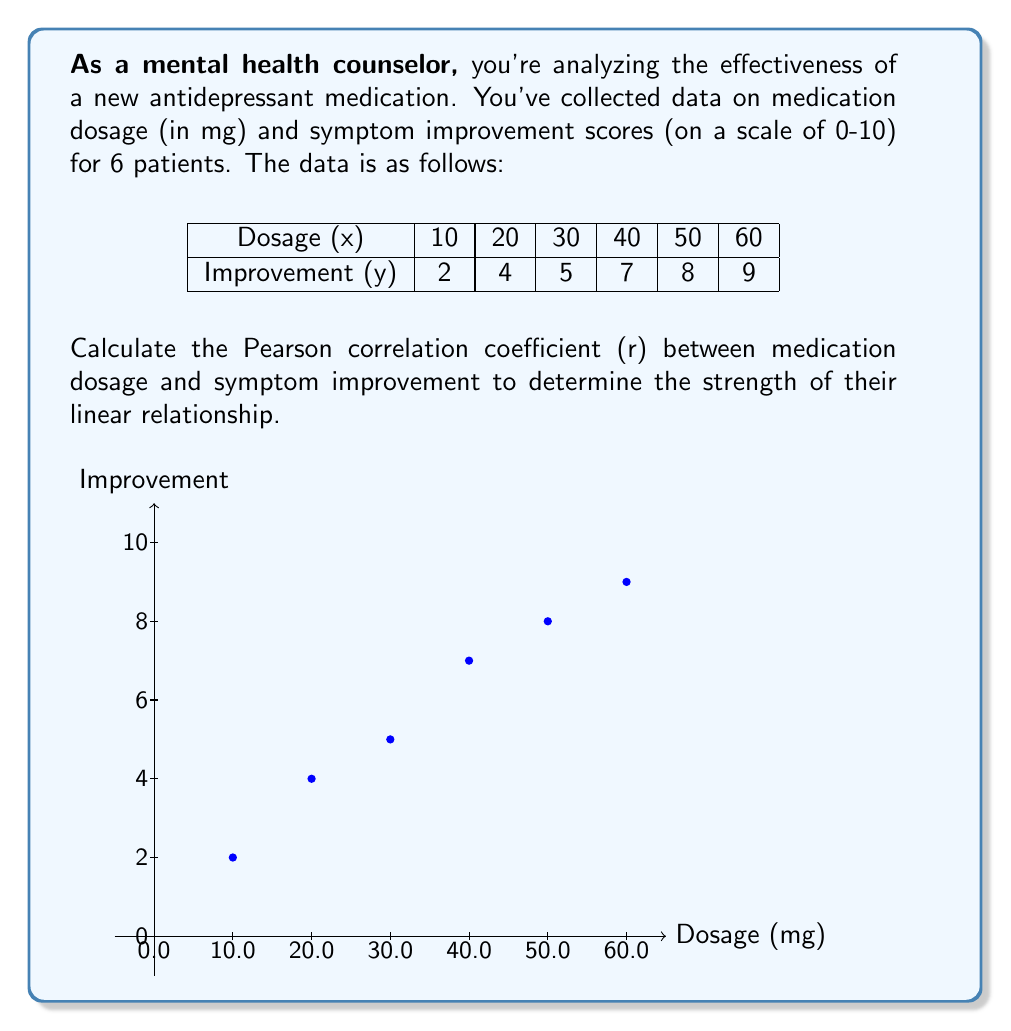Can you answer this question? To calculate the Pearson correlation coefficient (r), we'll use the formula:

$$ r = \frac{n\sum xy - \sum x \sum y}{\sqrt{[n\sum x^2 - (\sum x)^2][n\sum y^2 - (\sum y)^2]}} $$

Where n is the number of data points, x is the dosage, and y is the improvement score.

Step 1: Calculate the necessary sums:
$n = 6$
$\sum x = 10 + 20 + 30 + 40 + 50 + 60 = 210$
$\sum y = 2 + 4 + 5 + 7 + 8 + 9 = 35$
$\sum xy = (10)(2) + (20)(4) + (30)(5) + (40)(7) + (50)(8) + (60)(9) = 1620$
$\sum x^2 = 10^2 + 20^2 + 30^2 + 40^2 + 50^2 + 60^2 = 9100$
$\sum y^2 = 2^2 + 4^2 + 5^2 + 7^2 + 8^2 + 9^2 = 247$

Step 2: Substitute these values into the formula:

$$ r = \frac{6(1620) - (210)(35)}{\sqrt{[6(9100) - 210^2][6(247) - 35^2]}} $$

Step 3: Simplify:

$$ r = \frac{9720 - 7350}{\sqrt{(54600 - 44100)(1482 - 1225)}} $$

$$ r = \frac{2370}{\sqrt{(10500)(257)}} $$

$$ r = \frac{2370}{\sqrt{2698500}} $$

$$ r = \frac{2370}{1642.71} $$

$$ r \approx 0.9921 $$

The correlation coefficient is approximately 0.9921, indicating a very strong positive linear relationship between medication dosage and symptom improvement.
Answer: $r \approx 0.9921$ 